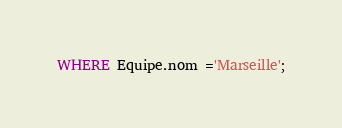<code> <loc_0><loc_0><loc_500><loc_500><_SQL_>WHERE Equipe.nom ='Marseille';</code> 